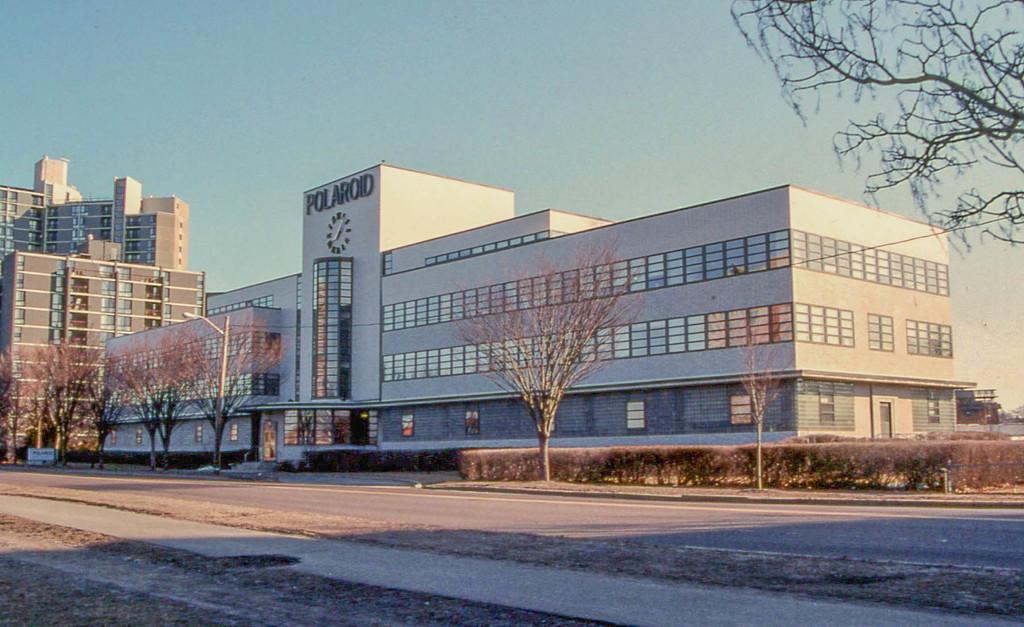Describe this image in one or two sentences. In the picture we can see a huge building with a clock to it and a name on it as Polaroid and to the building we can see glass windows and near the building we can see some trees and a pole with light and beside the building we can see other buildings with some floors and glasses in it and behind the building we can see a sky. 